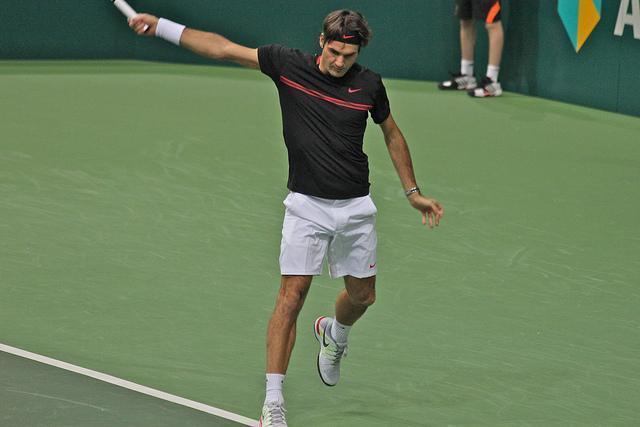How many tennis players are shown in the picture?
Give a very brief answer. 1. How many people are in the picture?
Give a very brief answer. 2. How many people are visible?
Give a very brief answer. 2. 